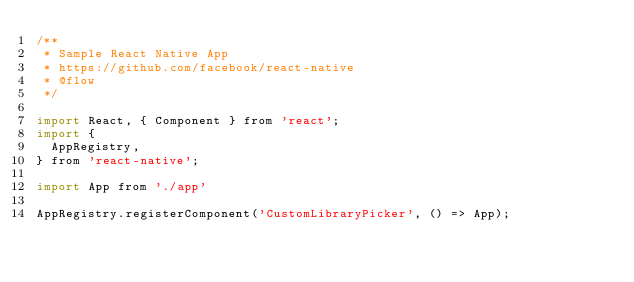<code> <loc_0><loc_0><loc_500><loc_500><_JavaScript_>/**
 * Sample React Native App
 * https://github.com/facebook/react-native
 * @flow
 */

import React, { Component } from 'react';
import {
  AppRegistry,
} from 'react-native';

import App from './app'

AppRegistry.registerComponent('CustomLibraryPicker', () => App);</code> 